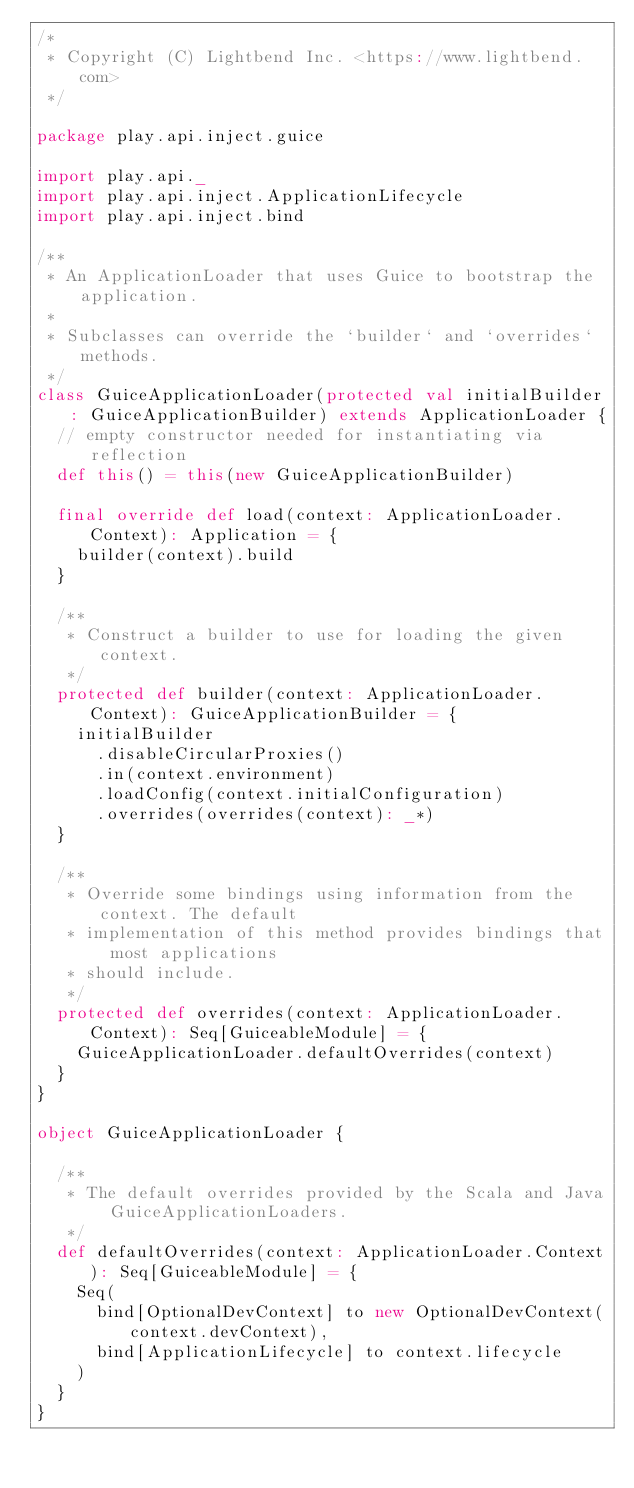<code> <loc_0><loc_0><loc_500><loc_500><_Scala_>/*
 * Copyright (C) Lightbend Inc. <https://www.lightbend.com>
 */

package play.api.inject.guice

import play.api._
import play.api.inject.ApplicationLifecycle
import play.api.inject.bind

/**
 * An ApplicationLoader that uses Guice to bootstrap the application.
 *
 * Subclasses can override the `builder` and `overrides` methods.
 */
class GuiceApplicationLoader(protected val initialBuilder: GuiceApplicationBuilder) extends ApplicationLoader {
  // empty constructor needed for instantiating via reflection
  def this() = this(new GuiceApplicationBuilder)

  final override def load(context: ApplicationLoader.Context): Application = {
    builder(context).build
  }

  /**
   * Construct a builder to use for loading the given context.
   */
  protected def builder(context: ApplicationLoader.Context): GuiceApplicationBuilder = {
    initialBuilder
      .disableCircularProxies()
      .in(context.environment)
      .loadConfig(context.initialConfiguration)
      .overrides(overrides(context): _*)
  }

  /**
   * Override some bindings using information from the context. The default
   * implementation of this method provides bindings that most applications
   * should include.
   */
  protected def overrides(context: ApplicationLoader.Context): Seq[GuiceableModule] = {
    GuiceApplicationLoader.defaultOverrides(context)
  }
}

object GuiceApplicationLoader {

  /**
   * The default overrides provided by the Scala and Java GuiceApplicationLoaders.
   */
  def defaultOverrides(context: ApplicationLoader.Context): Seq[GuiceableModule] = {
    Seq(
      bind[OptionalDevContext] to new OptionalDevContext(context.devContext),
      bind[ApplicationLifecycle] to context.lifecycle
    )
  }
}
</code> 